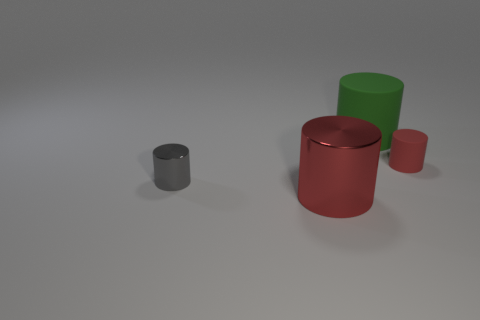How many red cylinders must be subtracted to get 1 red cylinders? 1 Subtract all tiny gray cylinders. How many cylinders are left? 3 Add 2 large yellow metal cubes. How many objects exist? 6 Subtract all red cylinders. How many cylinders are left? 2 Subtract all purple spheres. How many yellow cylinders are left? 0 Subtract all gray cylinders. Subtract all gray objects. How many objects are left? 2 Add 3 big red shiny cylinders. How many big red shiny cylinders are left? 4 Add 2 large balls. How many large balls exist? 2 Subtract 0 blue blocks. How many objects are left? 4 Subtract all gray cylinders. Subtract all gray balls. How many cylinders are left? 3 